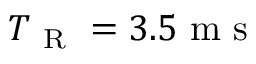Convert formula to latex. <formula><loc_0><loc_0><loc_500><loc_500>T _ { R } = 3 . 5 m s</formula> 